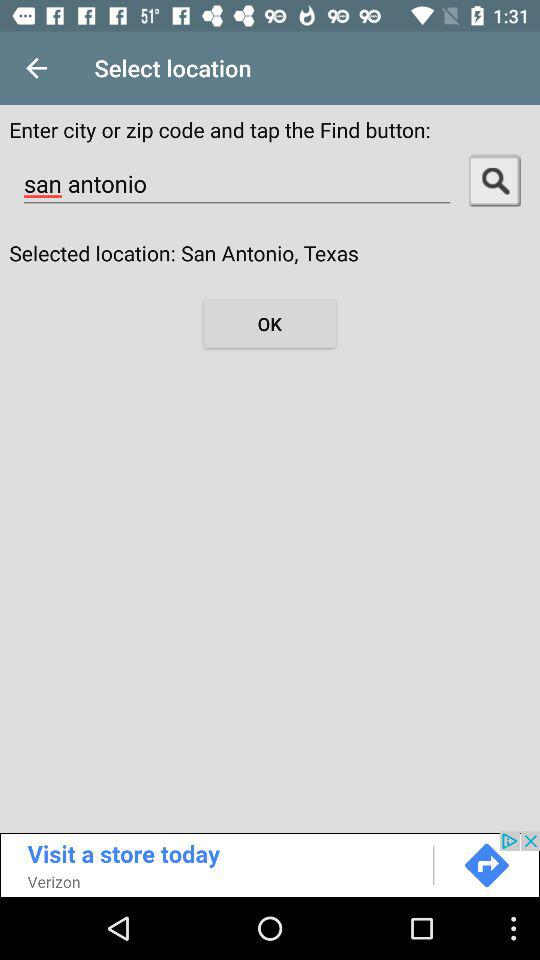What is the selected location? The selected location is San Antonio, Texas. 